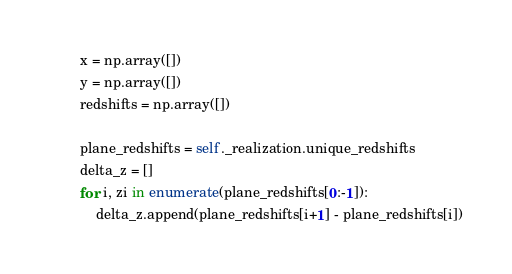Convert code to text. <code><loc_0><loc_0><loc_500><loc_500><_Python_>        x = np.array([])
        y = np.array([])
        redshifts = np.array([])

        plane_redshifts = self._realization.unique_redshifts
        delta_z = []
        for i, zi in enumerate(plane_redshifts[0:-1]):
            delta_z.append(plane_redshifts[i+1] - plane_redshifts[i])
</code> 